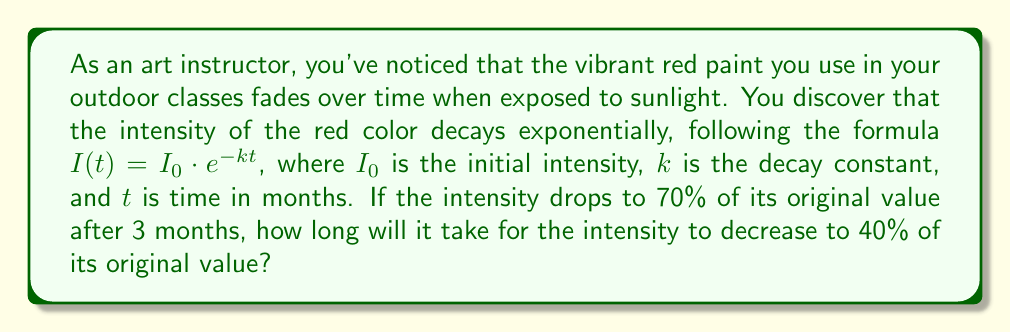Show me your answer to this math problem. Let's approach this step-by-step:

1) We're given the exponential decay formula: $I(t) = I_0 \cdot e^{-kt}$

2) After 3 months, the intensity is 70% of the original. Let's use this to find $k$:
   
   $0.7I_0 = I_0 \cdot e^{-3k}$

3) Simplify:
   
   $0.7 = e^{-3k}$

4) Take natural log of both sides:
   
   $\ln(0.7) = -3k$

5) Solve for $k$:
   
   $k = -\frac{\ln(0.7)}{3} \approx 0.1178$

6) Now, let's use this $k$ to find when the intensity reaches 40%:
   
   $0.4I_0 = I_0 \cdot e^{-0.1178t}$

7) Simplify:
   
   $0.4 = e^{-0.1178t}$

8) Take natural log of both sides:
   
   $\ln(0.4) = -0.1178t$

9) Solve for $t$:
   
   $t = -\frac{\ln(0.4)}{0.1178} \approx 7.7097$

Therefore, it will take approximately 7.71 months for the intensity to decrease to 40% of its original value.
Answer: 7.71 months 